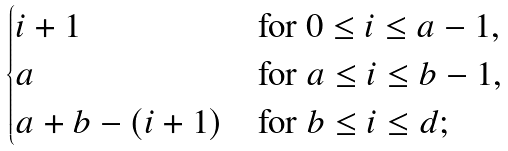<formula> <loc_0><loc_0><loc_500><loc_500>\begin{cases} i + 1 & \text {for $0 \leq i \leq a-1$,} \\ a & \text {for $a \leq i \leq b-1$,} \\ a + b - ( i + 1 ) & \text {for $b \leq i \leq d$;} \end{cases}</formula> 